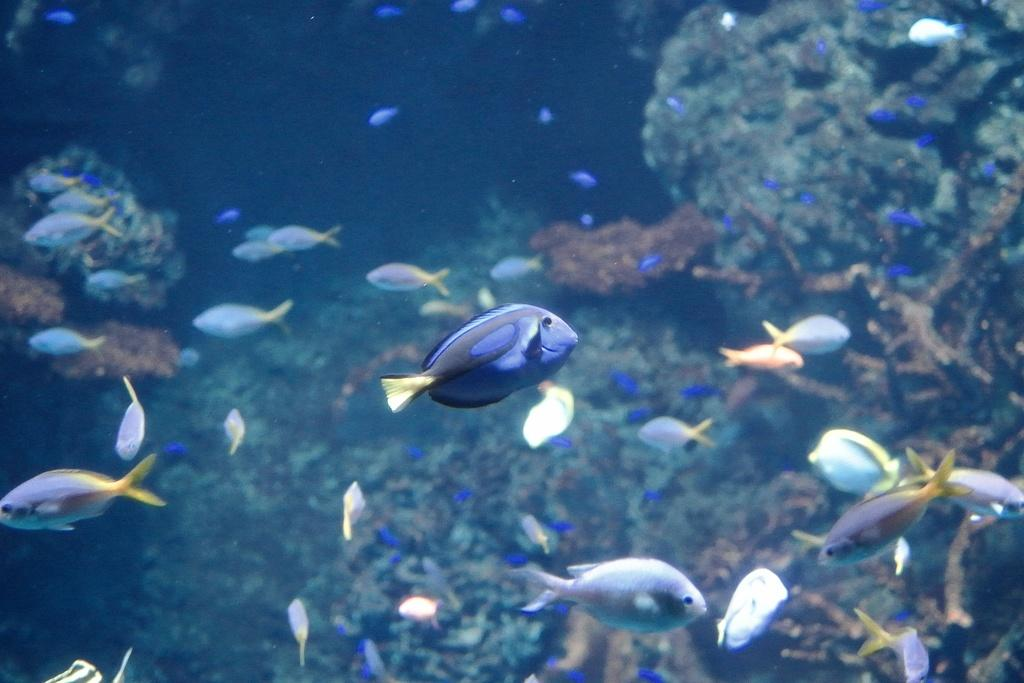What type of animals can be seen in the water in the image? There are fishes in the water in the image. What else can be seen in the water besides the fishes? There are water plants in the water in the image. How many women are visible in the image? There are no women present in the image; it features fishes and water plants in the water. Is the existence of clover mentioned or depicted in the image? There is no mention or depiction of clover in the image. 